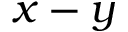Convert formula to latex. <formula><loc_0><loc_0><loc_500><loc_500>x - y</formula> 